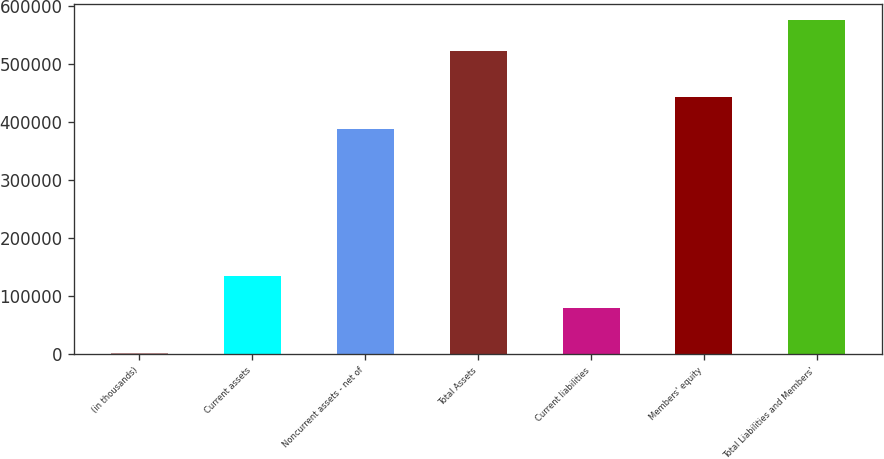<chart> <loc_0><loc_0><loc_500><loc_500><bar_chart><fcel>(in thousands)<fcel>Current assets<fcel>Noncurrent assets - net of<fcel>Total Assets<fcel>Current liabilities<fcel>Members' equity<fcel>Total Liabilities and Members'<nl><fcel>2004<fcel>134596<fcel>388982<fcel>523578<fcel>80310<fcel>443268<fcel>575735<nl></chart> 